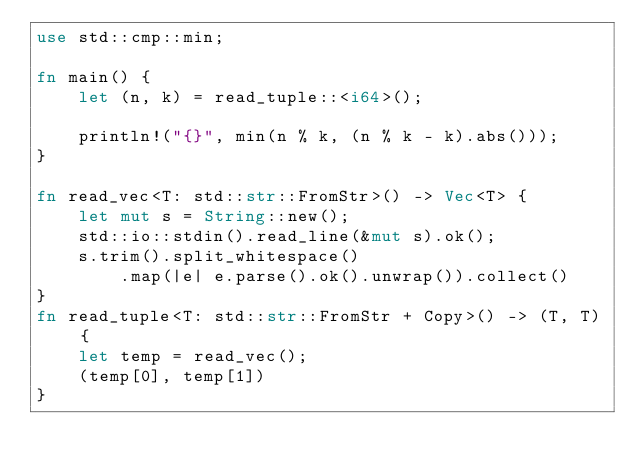Convert code to text. <code><loc_0><loc_0><loc_500><loc_500><_Rust_>use std::cmp::min;

fn main() {
    let (n, k) = read_tuple::<i64>();

    println!("{}", min(n % k, (n % k - k).abs()));
}

fn read_vec<T: std::str::FromStr>() -> Vec<T> {
    let mut s = String::new();
    std::io::stdin().read_line(&mut s).ok();
    s.trim().split_whitespace()
        .map(|e| e.parse().ok().unwrap()).collect()
}
fn read_tuple<T: std::str::FromStr + Copy>() -> (T, T) {
    let temp = read_vec();
    (temp[0], temp[1])
}

</code> 